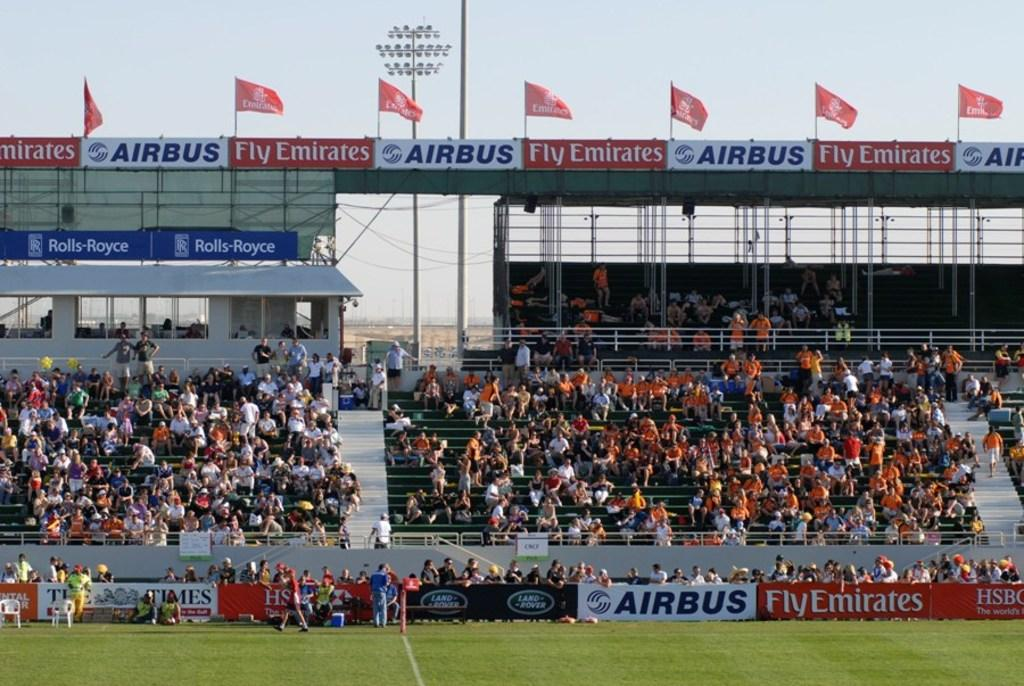<image>
Provide a brief description of the given image. A stadium filled with people has as for Airbus and Fly Emirates  in many places. 